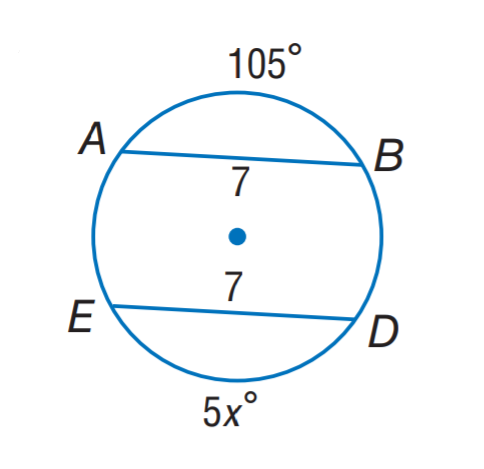Question: Find x.
Choices:
A. 7
B. 15
C. 21
D. 75
Answer with the letter. Answer: C 